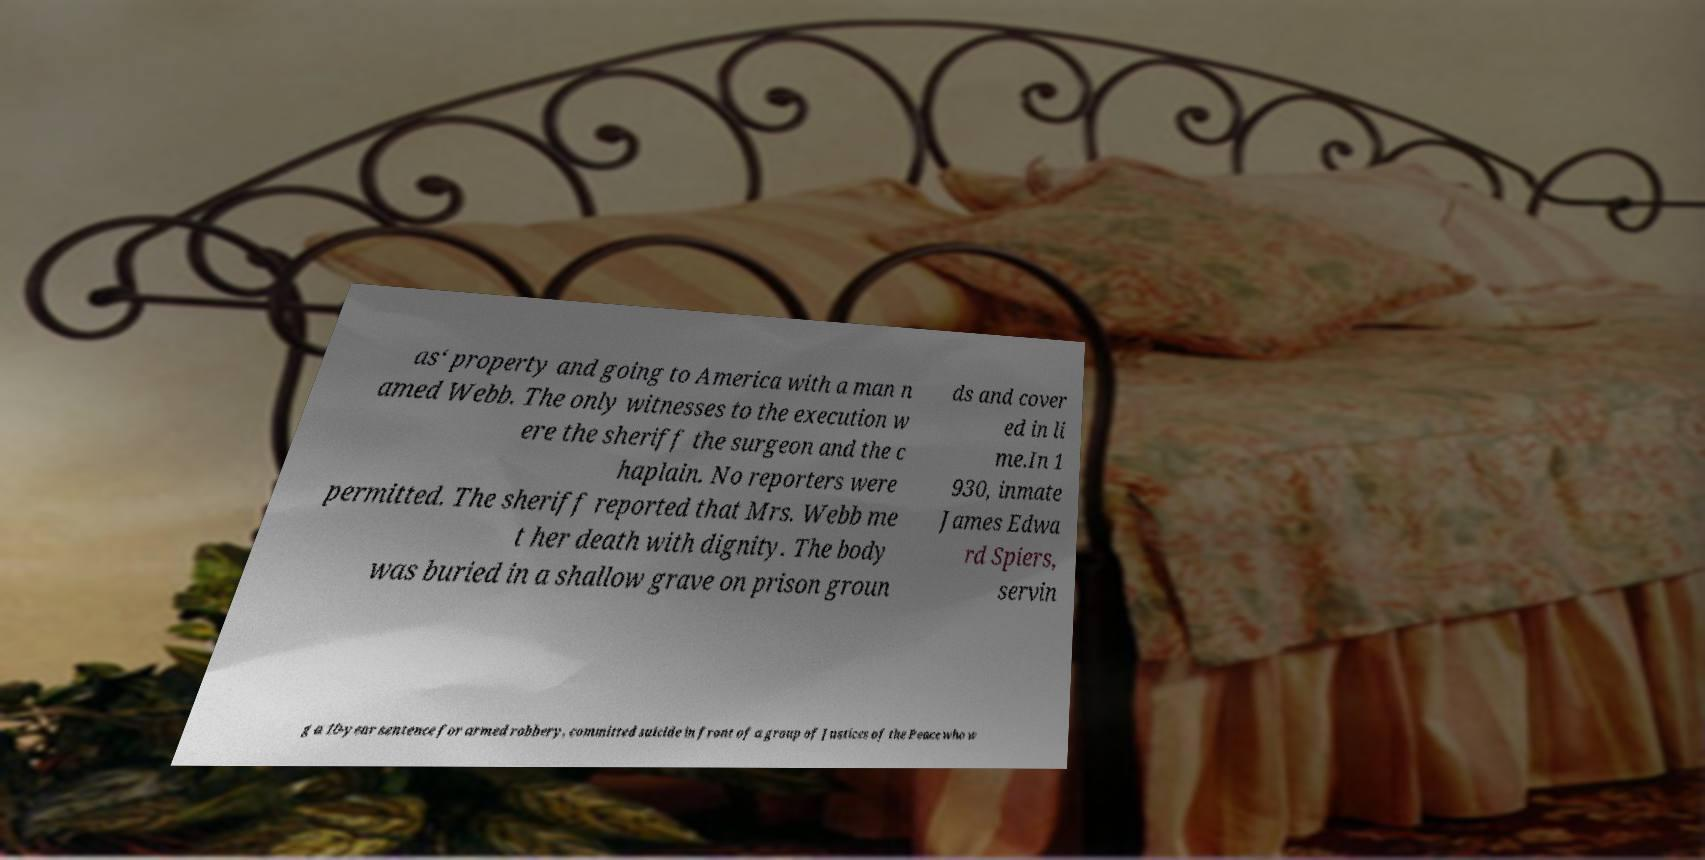Can you accurately transcribe the text from the provided image for me? as‘ property and going to America with a man n amed Webb. The only witnesses to the execution w ere the sheriff the surgeon and the c haplain. No reporters were permitted. The sheriff reported that Mrs. Webb me t her death with dignity. The body was buried in a shallow grave on prison groun ds and cover ed in li me.In 1 930, inmate James Edwa rd Spiers, servin g a 10-year sentence for armed robbery, committed suicide in front of a group of Justices of the Peace who w 